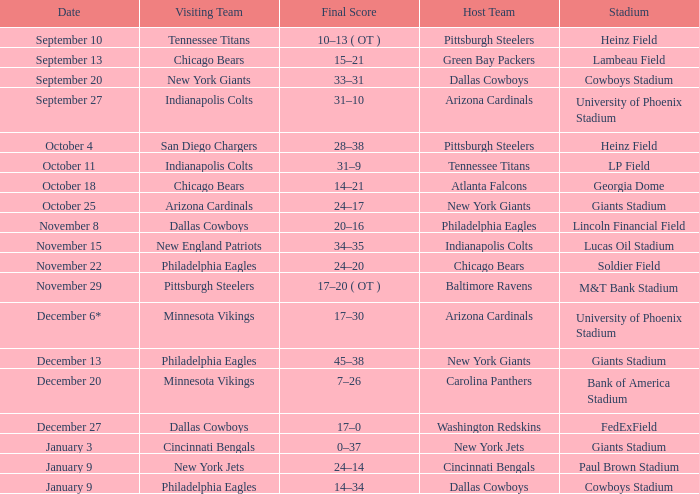Which team is visiting on october 4th? San Diego Chargers. 